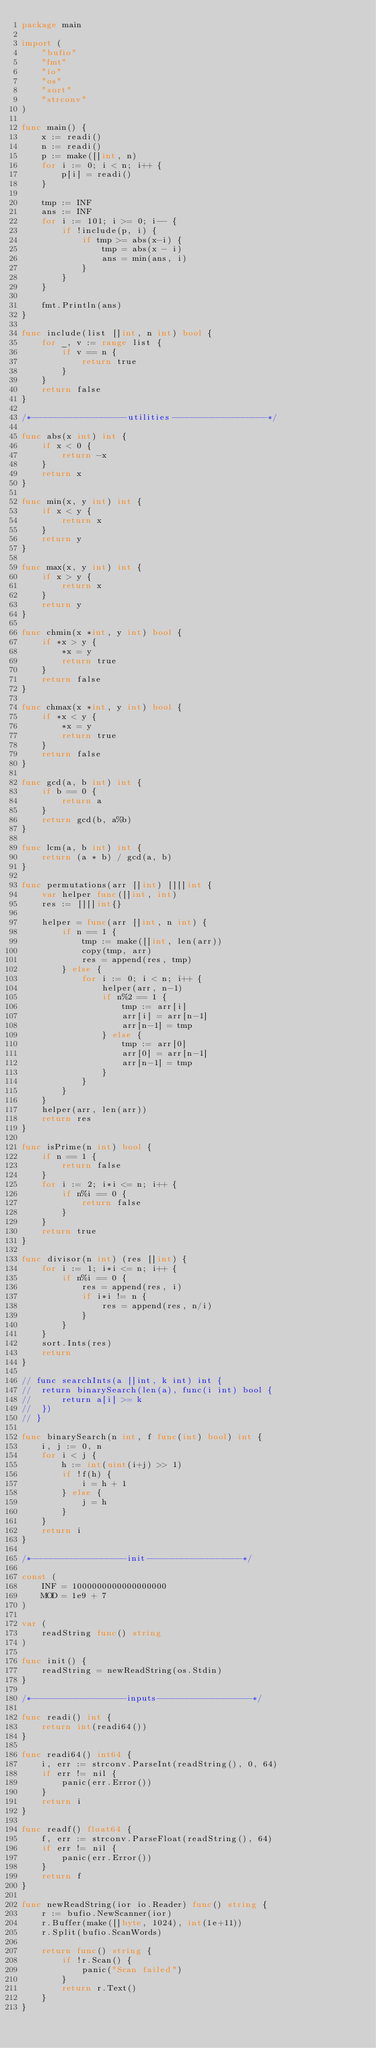<code> <loc_0><loc_0><loc_500><loc_500><_Go_>package main

import (
	"bufio"
	"fmt"
	"io"
	"os"
	"sort"
	"strconv"
)

func main() {
	x := readi()
	n := readi()
	p := make([]int, n)
	for i := 0; i < n; i++ {
		p[i] = readi()
	}

	tmp := INF
	ans := INF
	for i := 101; i >= 0; i-- {
		if !include(p, i) {
			if tmp >= abs(x-i) {
				tmp = abs(x - i)
				ans = min(ans, i)
			}
		}
	}

	fmt.Println(ans)
}

func include(list []int, n int) bool {
	for _, v := range list {
		if v == n {
			return true
		}
	}
	return false
}

/*-------------------utilities-------------------*/

func abs(x int) int {
	if x < 0 {
		return -x
	}
	return x
}

func min(x, y int) int {
	if x < y {
		return x
	}
	return y
}

func max(x, y int) int {
	if x > y {
		return x
	}
	return y
}

func chmin(x *int, y int) bool {
	if *x > y {
		*x = y
		return true
	}
	return false
}

func chmax(x *int, y int) bool {
	if *x < y {
		*x = y
		return true
	}
	return false
}

func gcd(a, b int) int {
	if b == 0 {
		return a
	}
	return gcd(b, a%b)
}

func lcm(a, b int) int {
	return (a * b) / gcd(a, b)
}

func permutations(arr []int) [][]int {
	var helper func([]int, int)
	res := [][]int{}

	helper = func(arr []int, n int) {
		if n == 1 {
			tmp := make([]int, len(arr))
			copy(tmp, arr)
			res = append(res, tmp)
		} else {
			for i := 0; i < n; i++ {
				helper(arr, n-1)
				if n%2 == 1 {
					tmp := arr[i]
					arr[i] = arr[n-1]
					arr[n-1] = tmp
				} else {
					tmp := arr[0]
					arr[0] = arr[n-1]
					arr[n-1] = tmp
				}
			}
		}
	}
	helper(arr, len(arr))
	return res
}

func isPrime(n int) bool {
	if n == 1 {
		return false
	}
	for i := 2; i*i <= n; i++ {
		if n%i == 0 {
			return false
		}
	}
	return true
}

func divisor(n int) (res []int) {
	for i := 1; i*i <= n; i++ {
		if n%i == 0 {
			res = append(res, i)
			if i*i != n {
				res = append(res, n/i)
			}
		}
	}
	sort.Ints(res)
	return
}

// func searchInts(a []int, k int) int {
// 	return binarySearch(len(a), func(i int) bool {
// 		return a[i] >= k
// 	})
// }

func binarySearch(n int, f func(int) bool) int {
	i, j := 0, n
	for i < j {
		h := int(uint(i+j) >> 1)
		if !f(h) {
			i = h + 1
		} else {
			j = h
		}
	}
	return i
}

/*-------------------init-------------------*/

const (
	INF = 1000000000000000000
	MOD = 1e9 + 7
)

var (
	readString func() string
)

func init() {
	readString = newReadString(os.Stdin)
}

/*-------------------inputs-------------------*/

func readi() int {
	return int(readi64())
}

func readi64() int64 {
	i, err := strconv.ParseInt(readString(), 0, 64)
	if err != nil {
		panic(err.Error())
	}
	return i
}

func readf() float64 {
	f, err := strconv.ParseFloat(readString(), 64)
	if err != nil {
		panic(err.Error())
	}
	return f
}

func newReadString(ior io.Reader) func() string {
	r := bufio.NewScanner(ior)
	r.Buffer(make([]byte, 1024), int(1e+11))
	r.Split(bufio.ScanWords)

	return func() string {
		if !r.Scan() {
			panic("Scan failed")
		}
		return r.Text()
	}
}
</code> 